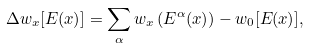<formula> <loc_0><loc_0><loc_500><loc_500>\Delta w _ { x } [ E ( x ) ] = \sum _ { \alpha } w _ { x } \left ( E ^ { \alpha } ( x ) \right ) - w _ { 0 } [ E ( x ) ] ,</formula> 